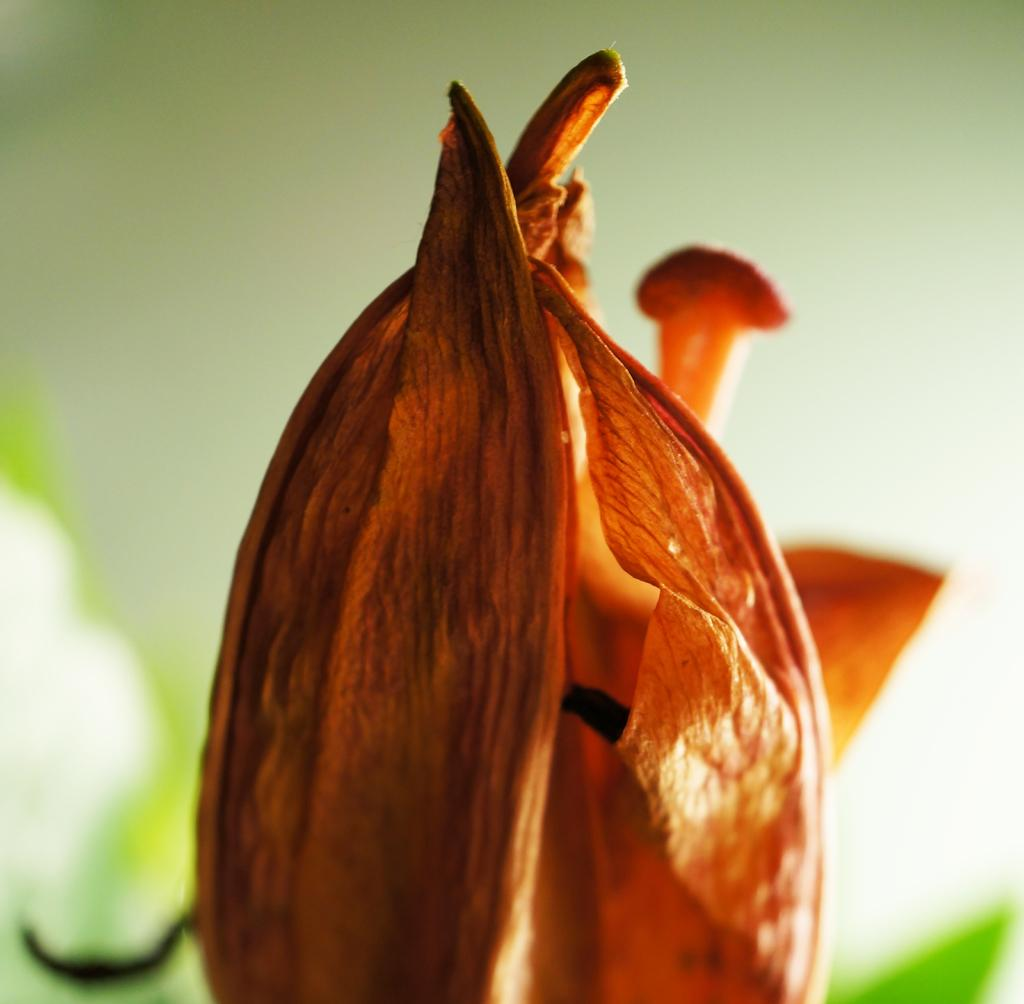What is the main subject of the image? There is a flower in the image. How would you describe the background of the image? The background has a blurred view. What colors can be seen on the flower? The flower has white and green colors. How many jellyfish can be seen swimming in the background of the image? There are no jellyfish present in the image; it features a flower with a blurred background. What type of icicle is hanging from the flower in the image? There is no icicle present in the image; the flower has white and green colors. 